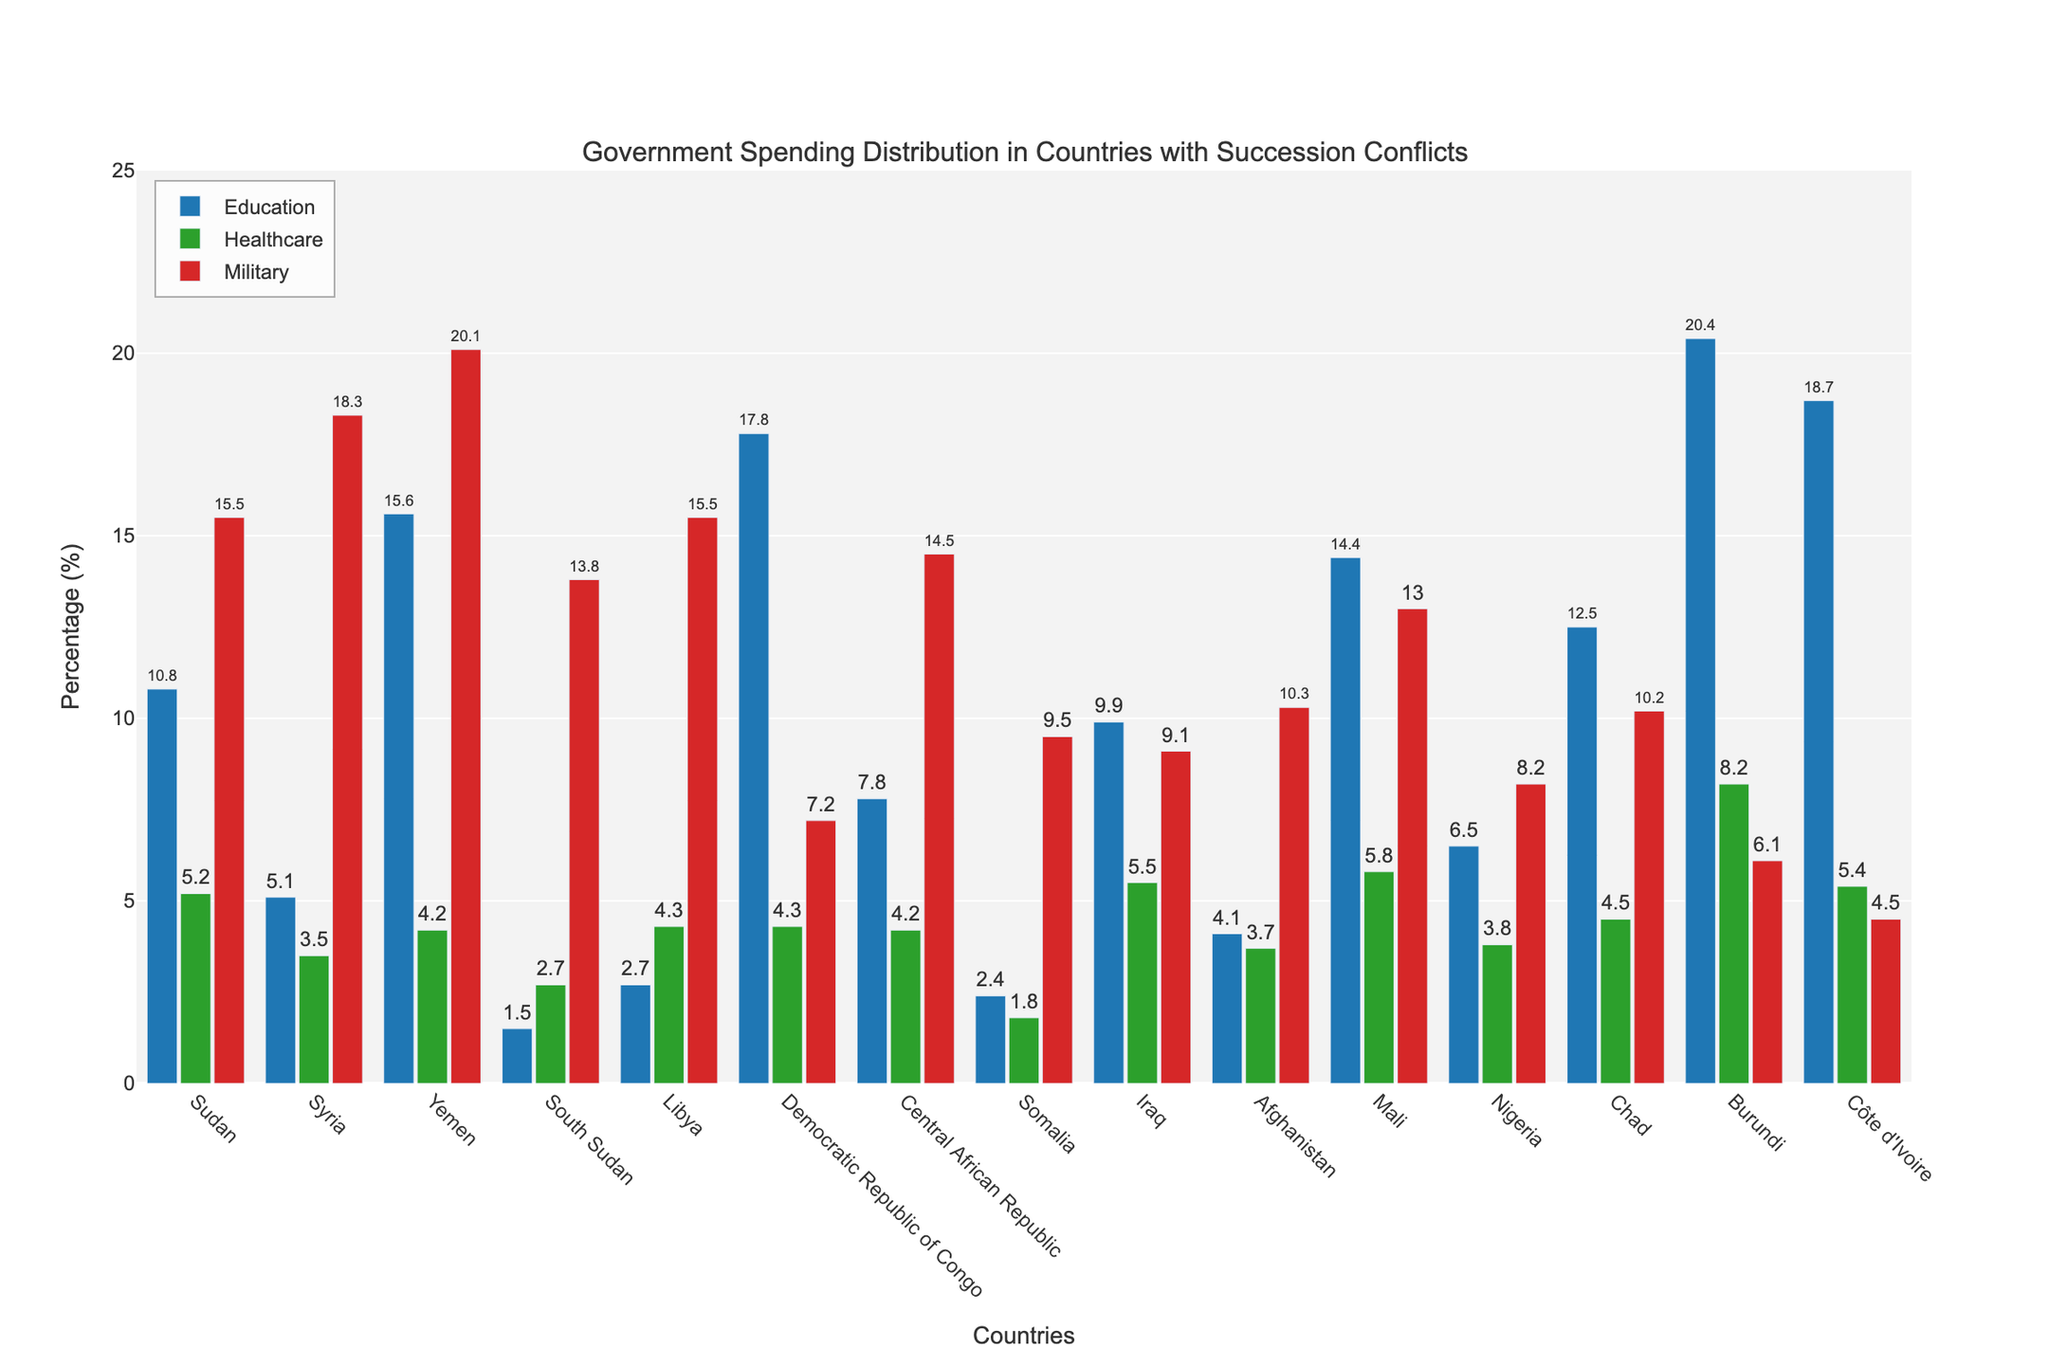What percentage of government spending is allocated to education in Sudan? Locate the bar for Sudan under the 'Education' category on the chart. The value displayed is the percentage allocated to education.
Answer: 10.8% Which country allocates the highest percentage of its government spending to the military? Identify the tallest bar in the 'Military' category, which represents the country spending the most on military. The tallest bar belongs to Yemen.
Answer: Yemen How does the government spending on healthcare in Afghanistan compare with that in Somalia? Find the bars for Afghanistan and Somalia in the 'Healthcare' category. The height of the bar indicates the percentage of spending. Afghanistan allocates 3.7%, while Somalia allocates 1.8%.
Answer: Afghanistan spends more than Somalia What is the total percentage allocated to education, healthcare, and military in Côte d'Ivoire? Sum the values of the bars for Côte d'Ivoire under the categories 'Education', 'Healthcare', and 'Military'. The values are 18.7% (Education) + 5.4% (Healthcare) + 4.5% (Military), totaling 28.6%.
Answer: 28.6% Which country has the lowest percentage allocated to healthcare, and what is the percentage? Identify the shortest bar in the 'Healthcare' category. The shortest bar belongs to Somalia.
Answer: Somalia, 1.8% Is the percentage of government spending on the military in Libya greater than that in Chad? Compare the heights of the bars representing Libya and Chad under the 'Military' category. Libya allocates 15.5%, while Chad allocates 10.2%.
Answer: Yes What is the average percentage of government spending on education across all the listed countries? Add the percentages for 'Education' from all the countries and then divide by the number of countries. The percentages are: 10.8, 5.1, 15.6, 1.5, 2.7, 17.8, 7.8, 2.4, 9.9, 4.1, 14.4, 6.5, 12.5, 20.4, 18.7. Sum them up: 150.7, then divide by 15 (number of countries). 150.7/15 = 10.05.
Answer: 10.05% What are the top 3 countries in terms of healthcare spending? Find the three tallest bars in the 'Healthcare' category. The top 3 bars correspond to Burundi, Mali, and Iraq.
Answer: Burundi, Mali, Iraq How much more does Yemen spend on the military compared to South Sudan? Subtract the percentage of military spending in South Sudan from that in Yemen. Yemen spends 20.1%, South Sudan spends 13.8%. The difference is 20.1 - 13.8 = 6.3.
Answer: 6.3% Compare the spending on education and military in Chad. Which one is higher and by how much? Find the bars for Chad under 'Education' and 'Military' categories. Chad spends 12.5% on Education and 10.2% on Military. Subtract the military spending from the education spending to find the difference. 12.5 - 10.2 = 2.3.
Answer: Education, by 2.3% 